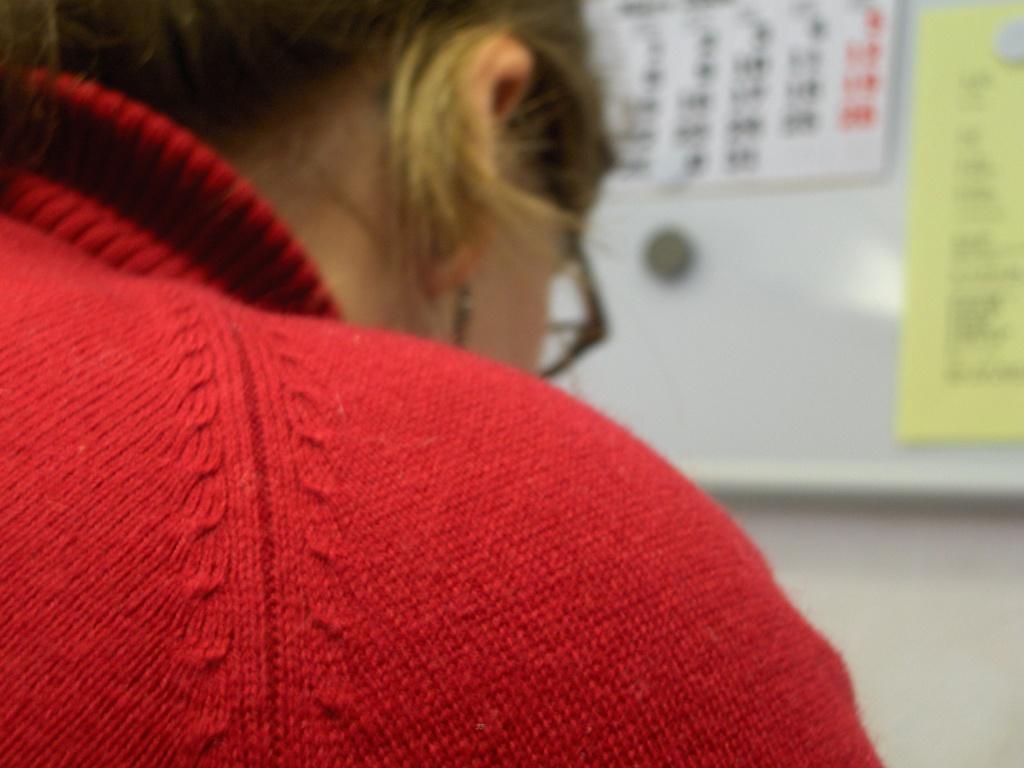Describe this image in one or two sentences. In this picture I can see there is a woman and she is wearing a red sweater and a spectacles. In the backdrop there is a wall, there is a calendar and a paper pasted on the wall. 